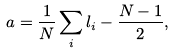Convert formula to latex. <formula><loc_0><loc_0><loc_500><loc_500>a = \frac { 1 } { N } \sum _ { i } l _ { i } - \frac { N - 1 } { 2 } ,</formula> 